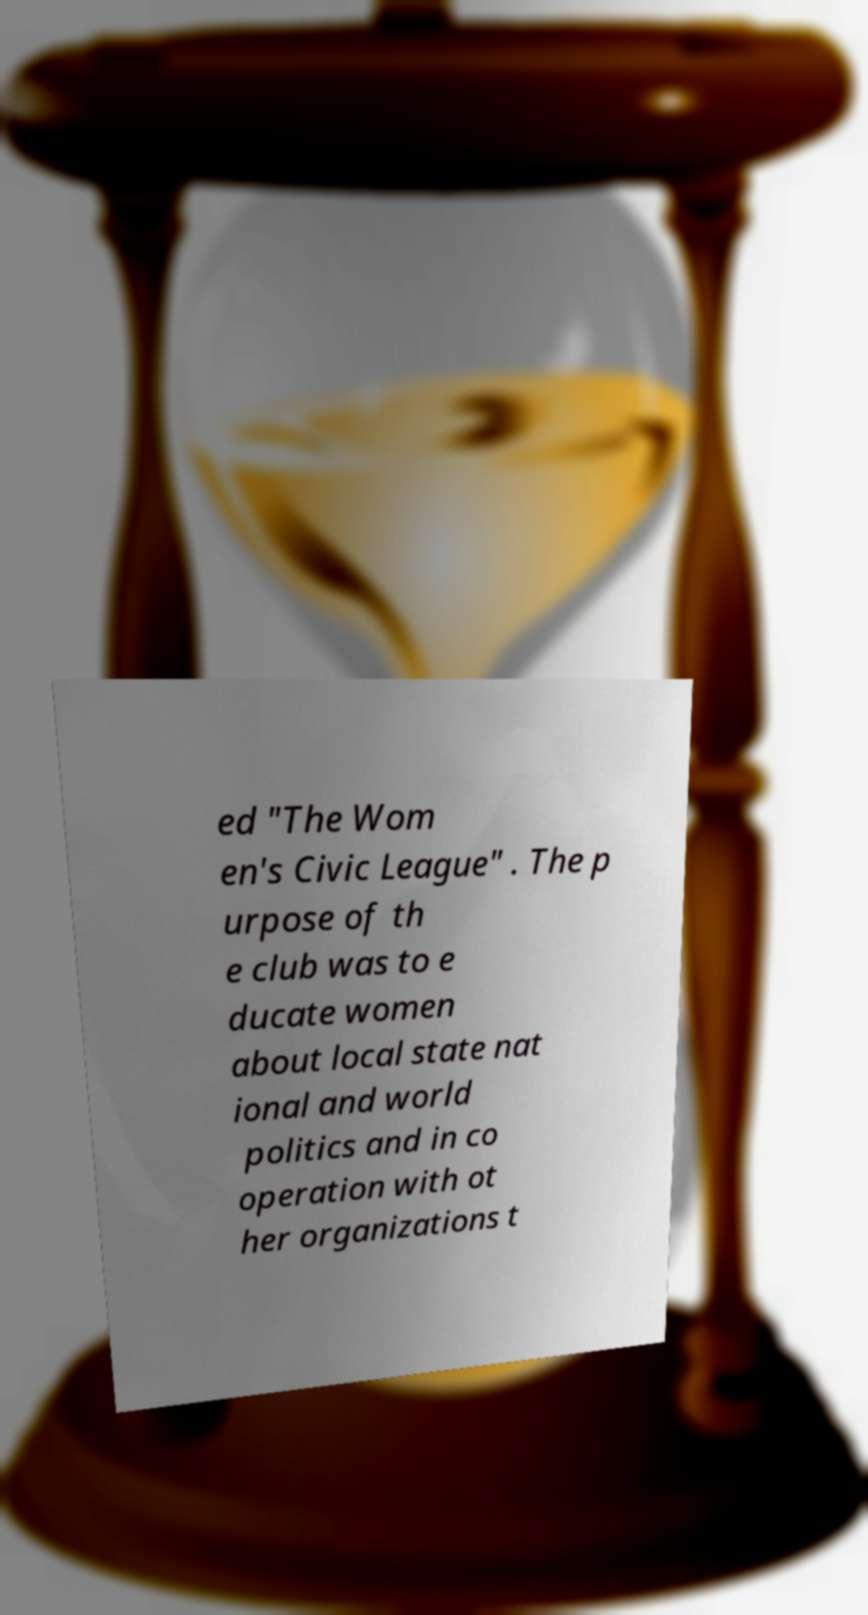Could you assist in decoding the text presented in this image and type it out clearly? ed "The Wom en's Civic League" . The p urpose of th e club was to e ducate women about local state nat ional and world politics and in co operation with ot her organizations t 